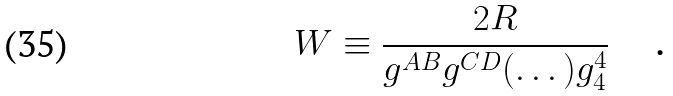<formula> <loc_0><loc_0><loc_500><loc_500>W \equiv \frac { 2 R } { g ^ { A B } g ^ { C D } ( \dots ) g _ { 4 } ^ { 4 } } \text { \quad .}</formula> 